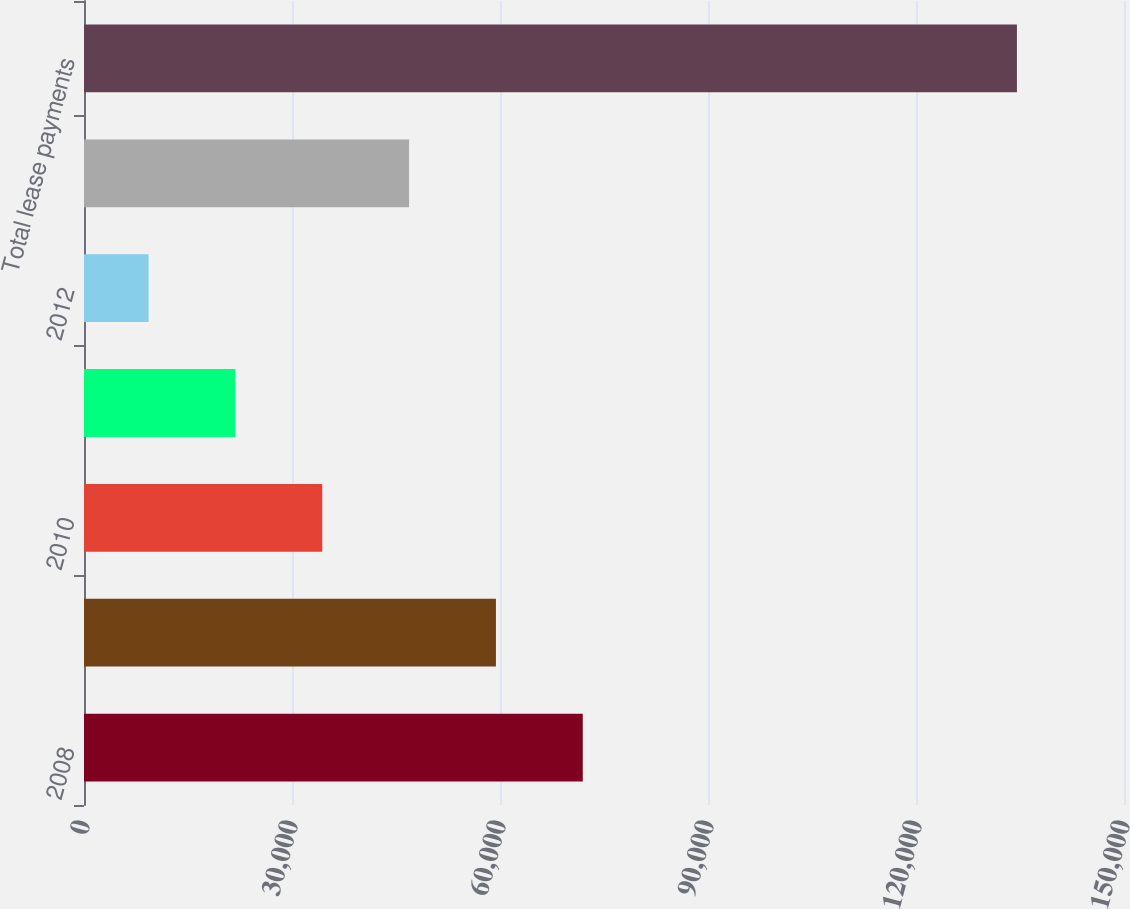Convert chart. <chart><loc_0><loc_0><loc_500><loc_500><bar_chart><fcel>2008<fcel>2009<fcel>2010<fcel>2011<fcel>2012<fcel>Thereafter<fcel>Total lease payments<nl><fcel>71936.5<fcel>59412.4<fcel>34364.2<fcel>21840.1<fcel>9316<fcel>46888.3<fcel>134557<nl></chart> 